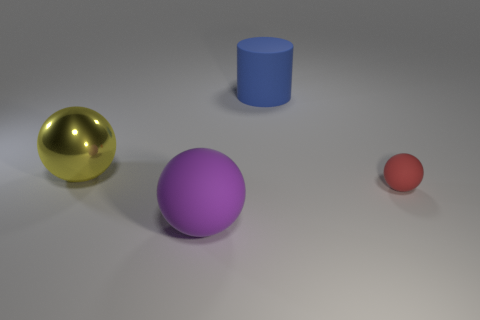There is a large blue thing; are there any purple matte things on the left side of it?
Offer a terse response. Yes. What color is the large rubber object in front of the object that is left of the big purple matte thing?
Keep it short and to the point. Purple. Is the number of yellow balls less than the number of rubber objects?
Provide a short and direct response. Yes. How many other large blue matte objects are the same shape as the blue object?
Make the answer very short. 0. There is a matte object that is the same size as the purple matte sphere; what is its color?
Provide a succinct answer. Blue. Are there the same number of red matte objects left of the metal ball and spheres right of the big blue object?
Ensure brevity in your answer.  No. Is there a blue matte cylinder of the same size as the purple sphere?
Your response must be concise. Yes. What is the size of the cylinder?
Your answer should be very brief. Large. Is the number of big rubber things that are in front of the blue rubber cylinder the same as the number of blue things?
Ensure brevity in your answer.  Yes. What number of other things are there of the same color as the big matte sphere?
Ensure brevity in your answer.  0. 